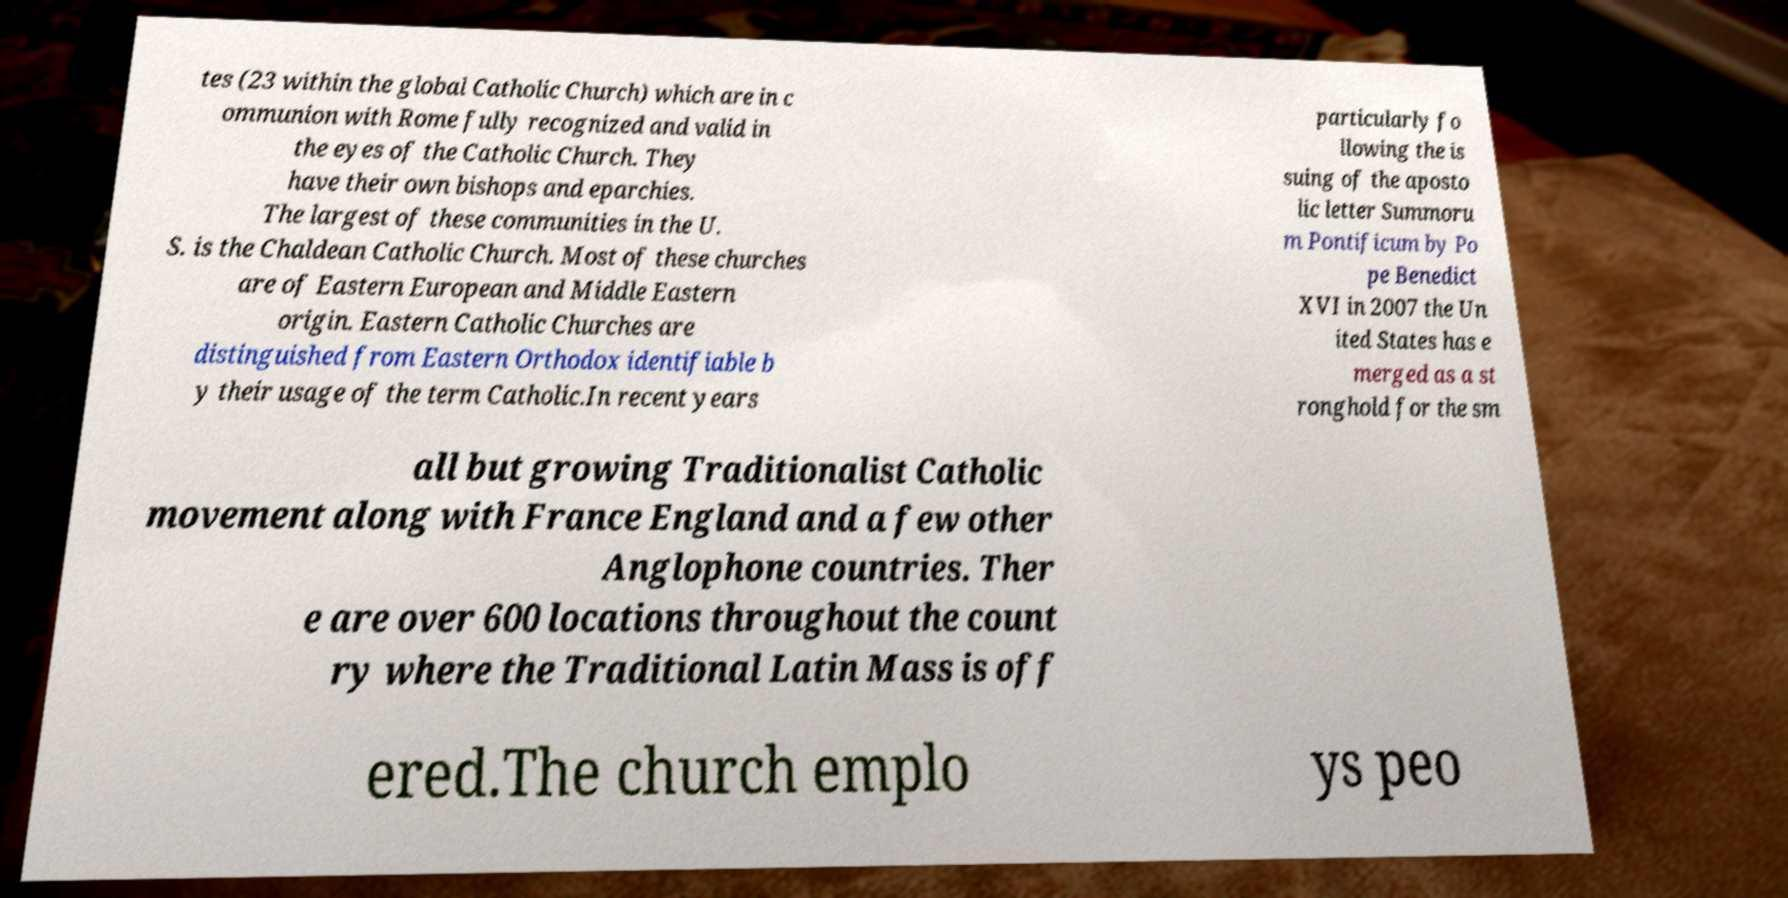For documentation purposes, I need the text within this image transcribed. Could you provide that? tes (23 within the global Catholic Church) which are in c ommunion with Rome fully recognized and valid in the eyes of the Catholic Church. They have their own bishops and eparchies. The largest of these communities in the U. S. is the Chaldean Catholic Church. Most of these churches are of Eastern European and Middle Eastern origin. Eastern Catholic Churches are distinguished from Eastern Orthodox identifiable b y their usage of the term Catholic.In recent years particularly fo llowing the is suing of the aposto lic letter Summoru m Pontificum by Po pe Benedict XVI in 2007 the Un ited States has e merged as a st ronghold for the sm all but growing Traditionalist Catholic movement along with France England and a few other Anglophone countries. Ther e are over 600 locations throughout the count ry where the Traditional Latin Mass is off ered.The church emplo ys peo 